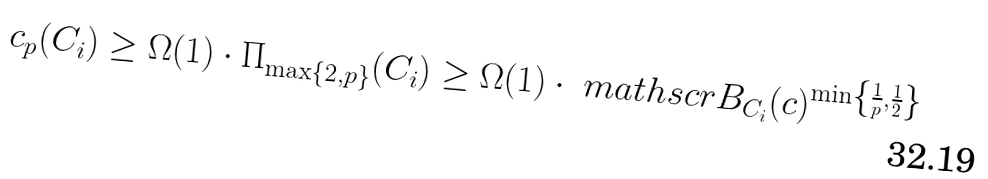Convert formula to latex. <formula><loc_0><loc_0><loc_500><loc_500>c _ { p } ( C _ { i } ) \geq \Omega ( 1 ) \cdot \Pi _ { \max \{ 2 , p \} } ( C _ { i } ) \geq \Omega ( 1 ) \cdot \ m a t h s c r { B } _ { C _ { i } } ( c ) ^ { \min \left \{ \frac { 1 } { p } , \frac { 1 } { 2 } \right \} }</formula> 